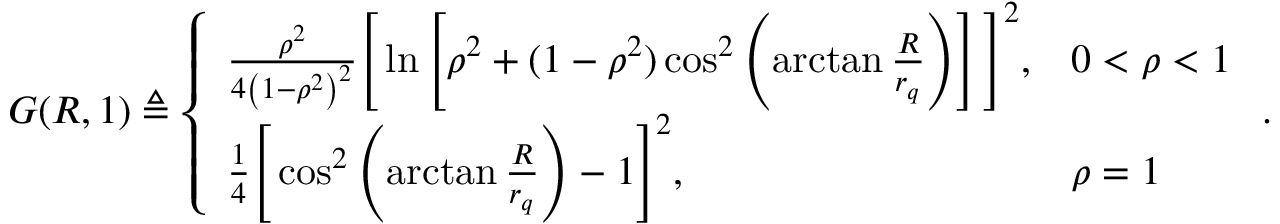Convert formula to latex. <formula><loc_0><loc_0><loc_500><loc_500>\begin{array} { r } { G ( R , 1 ) \triangle q \left \{ \begin{array} { l l } { \frac { \rho ^ { 2 } } { 4 \left ( 1 - \rho ^ { 2 } \right ) ^ { 2 } } \left [ \ln \left [ \rho ^ { 2 } + ( 1 - \rho ^ { 2 } ) \cos ^ { 2 } \left ( \arctan \frac { R } { r _ { q } } \right ) \right ] \right ] ^ { 2 } , } & { 0 < \rho < 1 } \\ { \frac { 1 } { 4 } \left [ \cos ^ { 2 } \left ( \arctan \frac { R } { r _ { q } } \right ) - 1 \right ] ^ { 2 } , } & { \rho = 1 } \end{array} . } \end{array}</formula> 